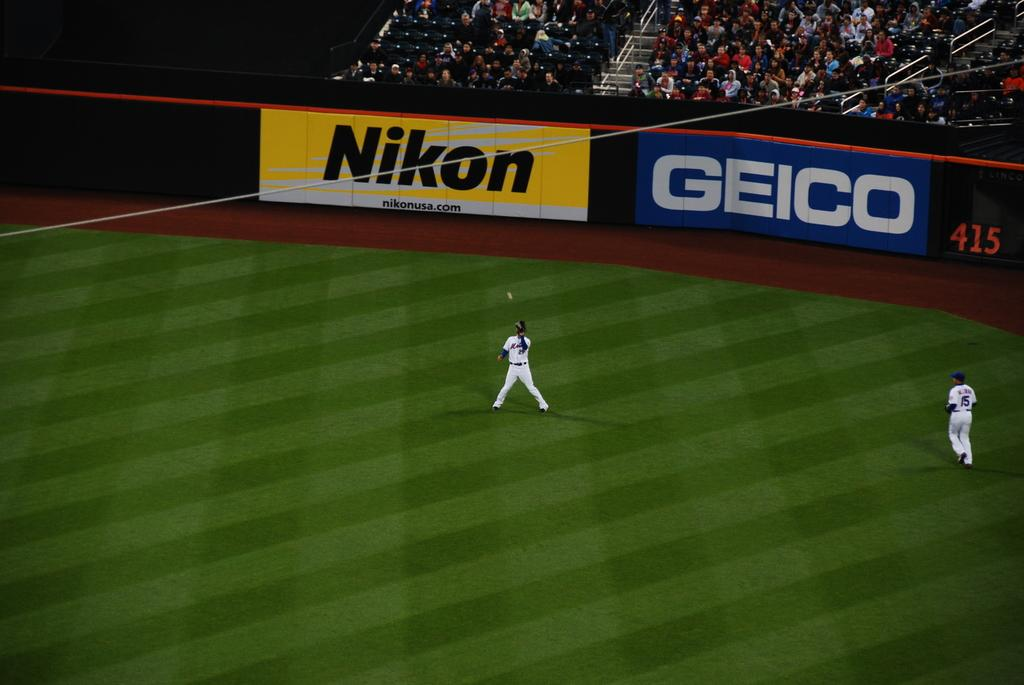<image>
Write a terse but informative summary of the picture. A baseball player is about to catch the ball in front of two huge Nikon and Geico advertising signs. 